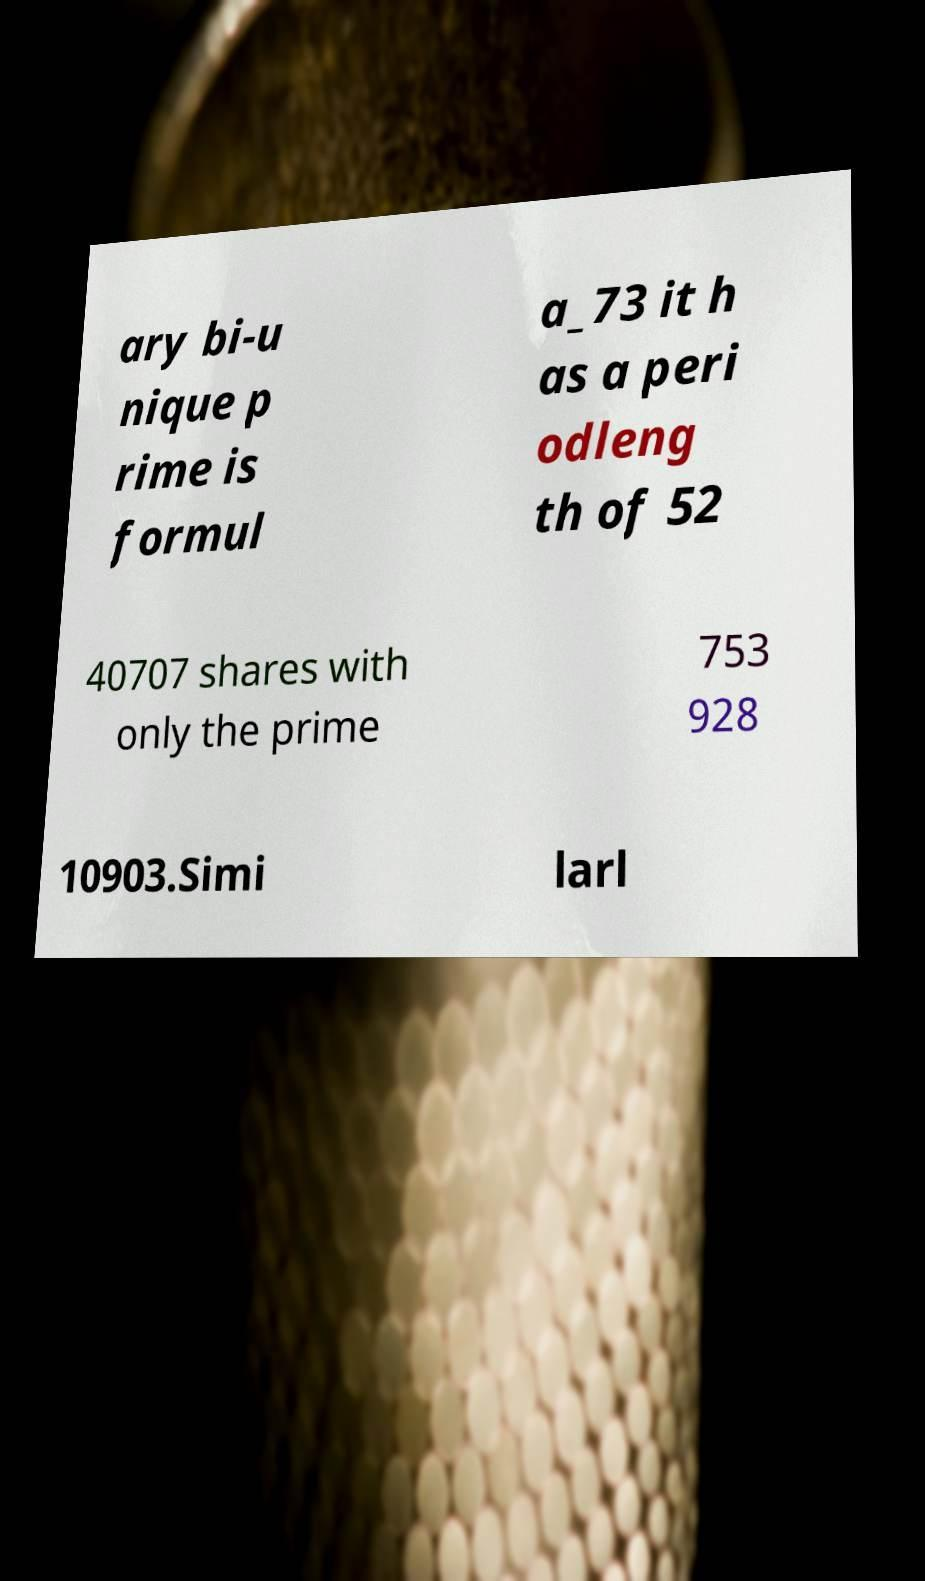Please identify and transcribe the text found in this image. ary bi-u nique p rime is formul a_73 it h as a peri odleng th of 52 40707 shares with only the prime 753 928 10903.Simi larl 